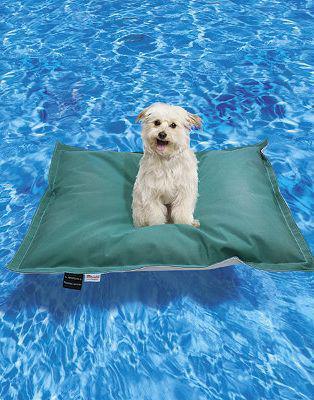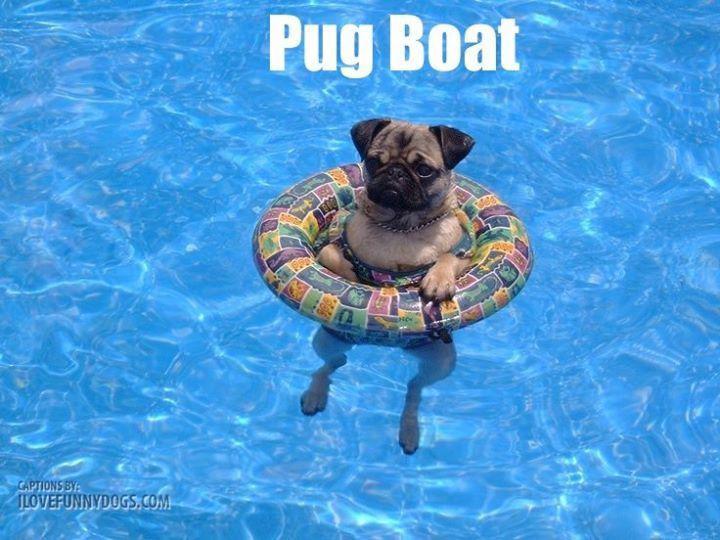The first image is the image on the left, the second image is the image on the right. For the images shown, is this caption "In at least one image there is a pug in an intertube with his legs hanging down." true? Answer yes or no. Yes. The first image is the image on the left, the second image is the image on the right. For the images shown, is this caption "there is a pug floating in a pool in an inter tube, the tube has a collage of images all over it" true? Answer yes or no. Yes. 